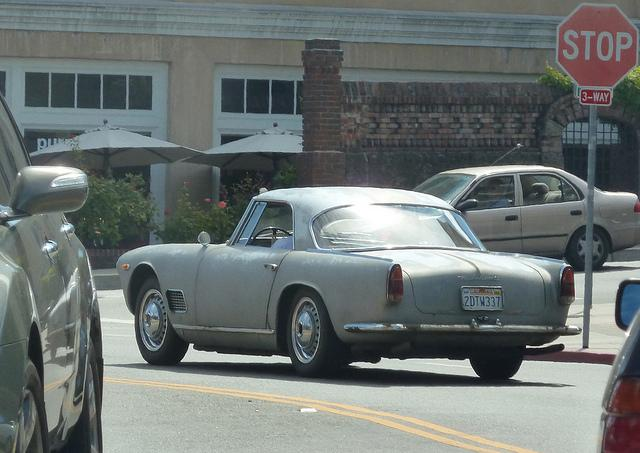How many turn options do cars entering this intersection have?

Choices:
A) one
B) two
C) five
D) none two 